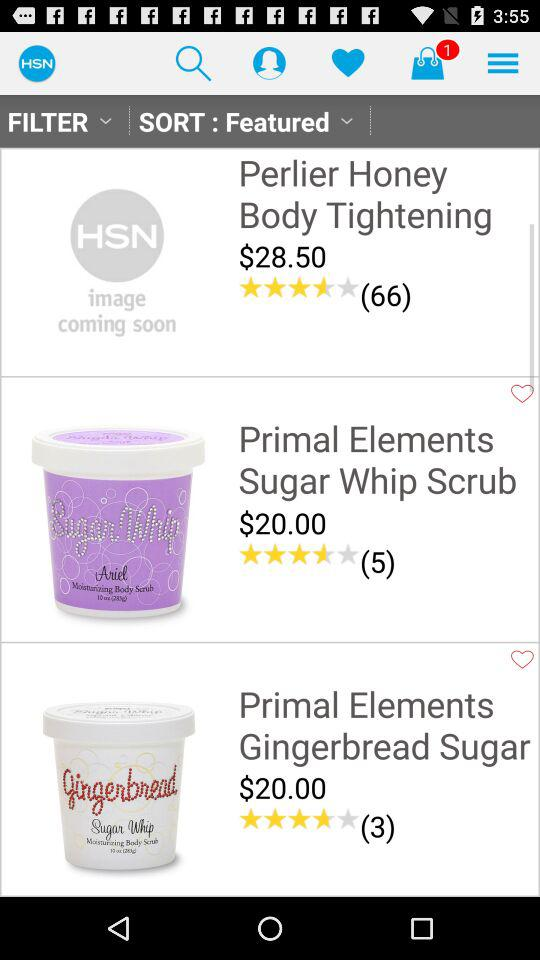What is the price of "Primal Elements Sugar Whip Scrub"? The price is $20.00. 